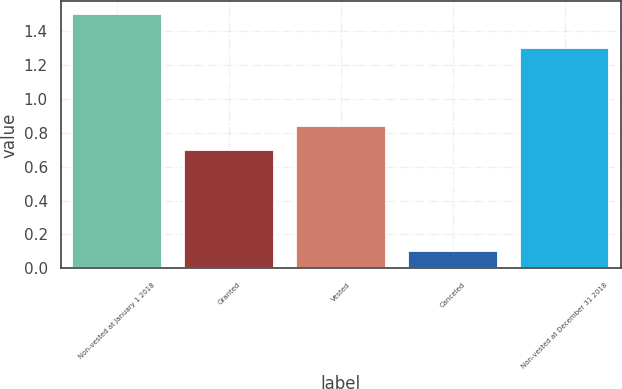<chart> <loc_0><loc_0><loc_500><loc_500><bar_chart><fcel>Non-vested at January 1 2018<fcel>Granted<fcel>Vested<fcel>Canceled<fcel>Non-vested at December 31 2018<nl><fcel>1.5<fcel>0.7<fcel>0.84<fcel>0.1<fcel>1.3<nl></chart> 